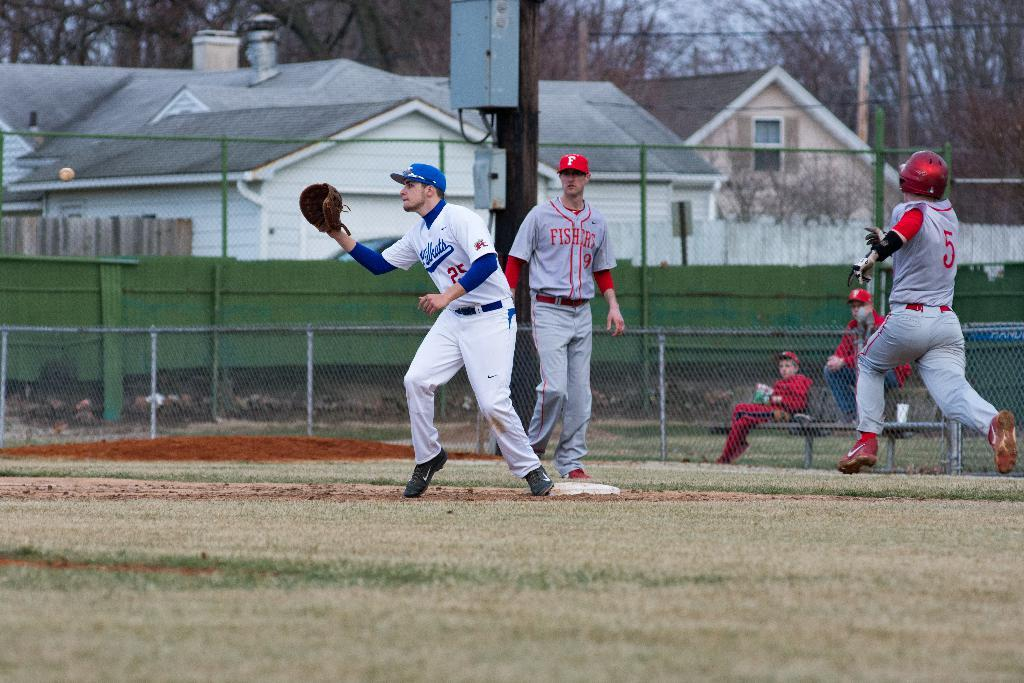<image>
Render a clear and concise summary of the photo. A baseball team is taking place where a player in a Fishers uniform runs to go to the base before he is out. 